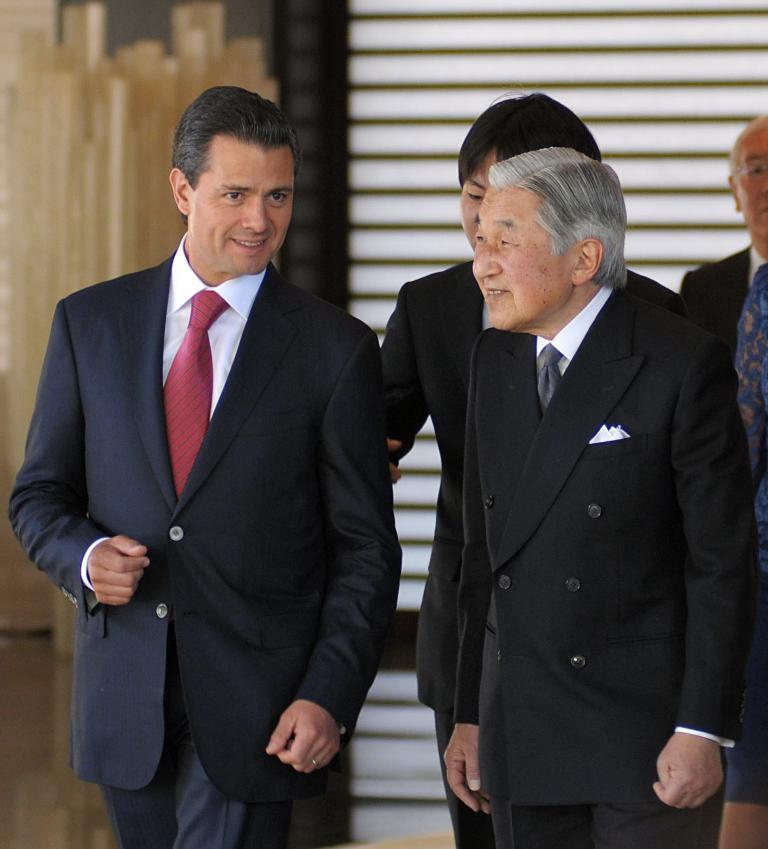How many individuals can be seen in the image? There are many people in the image. What can be seen in the background of the image? There is a wall visible in the background of the image. What type of oatmeal is being served to the people in the image? There is no oatmeal present in the image, and it is not mentioned that the people are being served any food. 